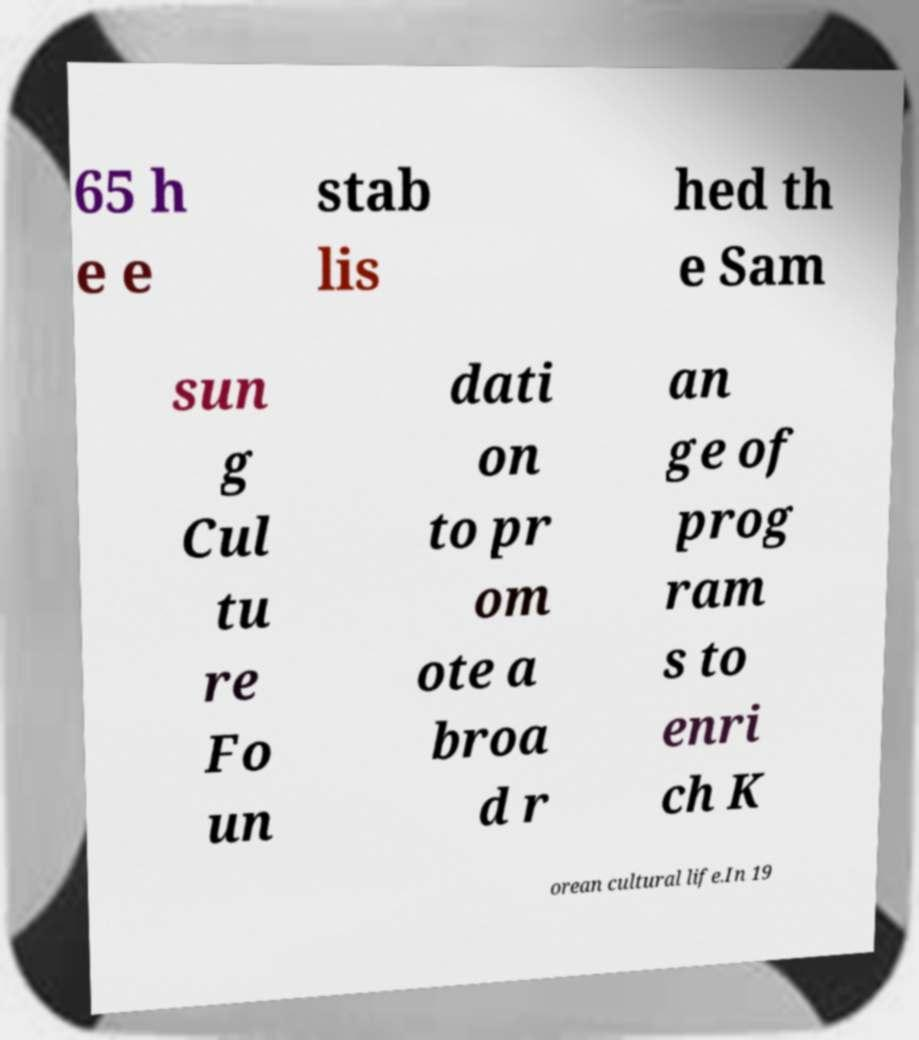Could you extract and type out the text from this image? 65 h e e stab lis hed th e Sam sun g Cul tu re Fo un dati on to pr om ote a broa d r an ge of prog ram s to enri ch K orean cultural life.In 19 